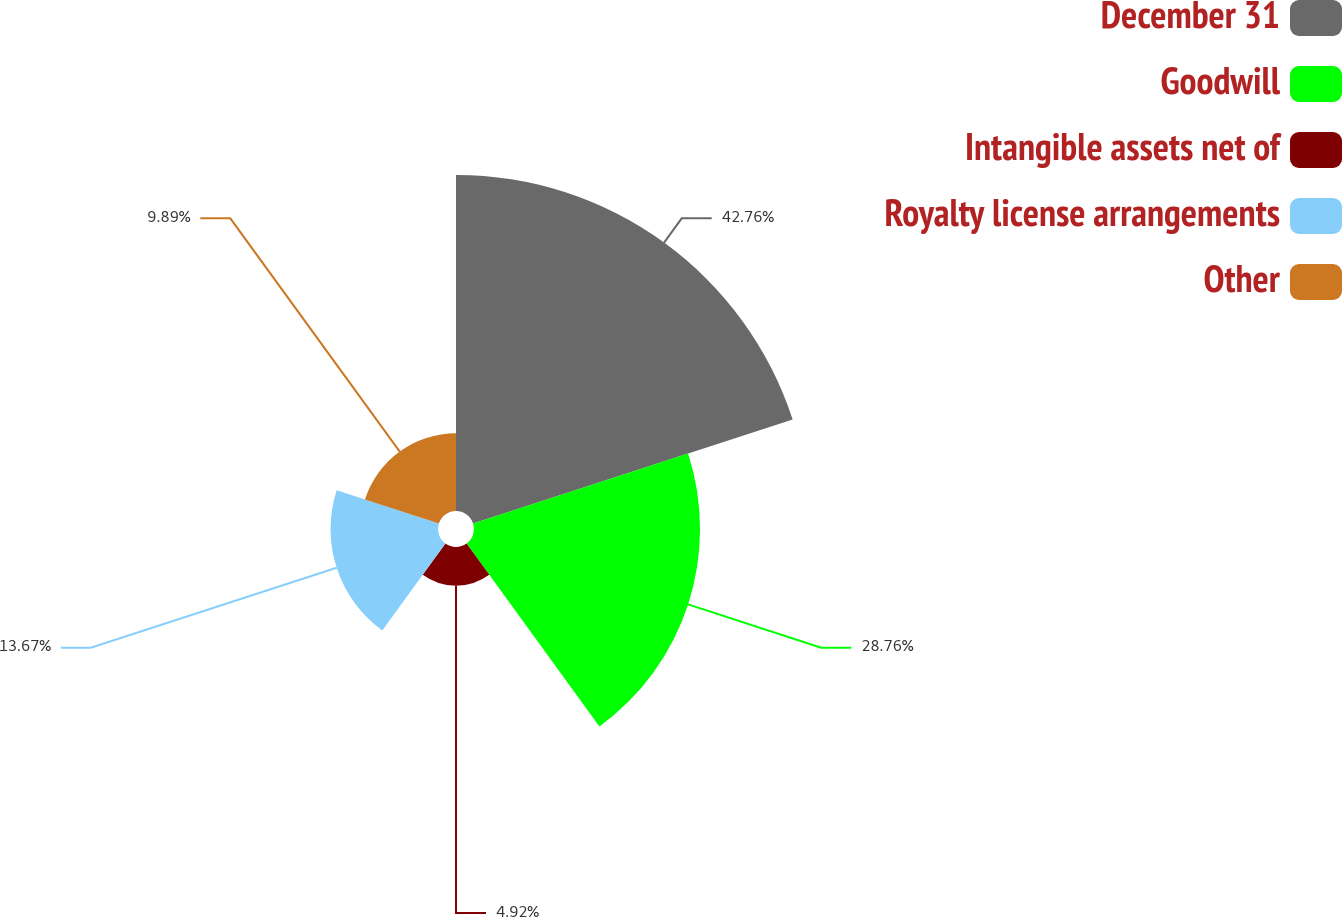Convert chart. <chart><loc_0><loc_0><loc_500><loc_500><pie_chart><fcel>December 31<fcel>Goodwill<fcel>Intangible assets net of<fcel>Royalty license arrangements<fcel>Other<nl><fcel>42.75%<fcel>28.76%<fcel>4.92%<fcel>13.67%<fcel>9.89%<nl></chart> 